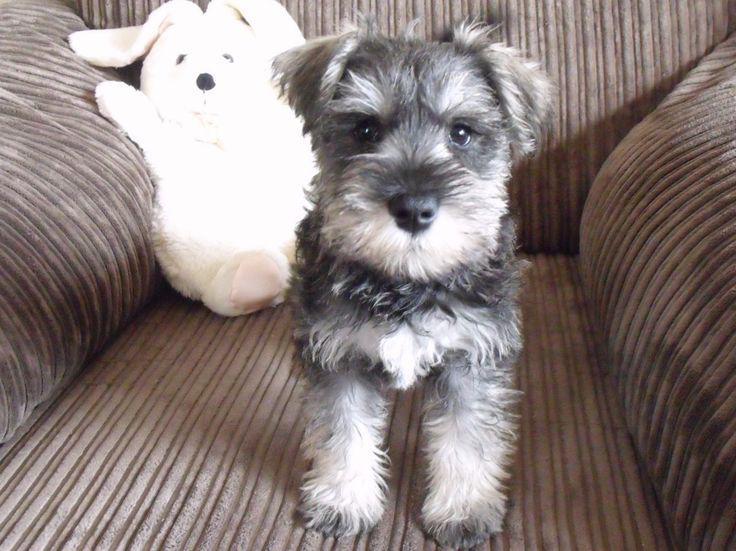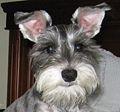The first image is the image on the left, the second image is the image on the right. For the images shown, is this caption "One of the images contains a dog with only the head showing." true? Answer yes or no. Yes. 